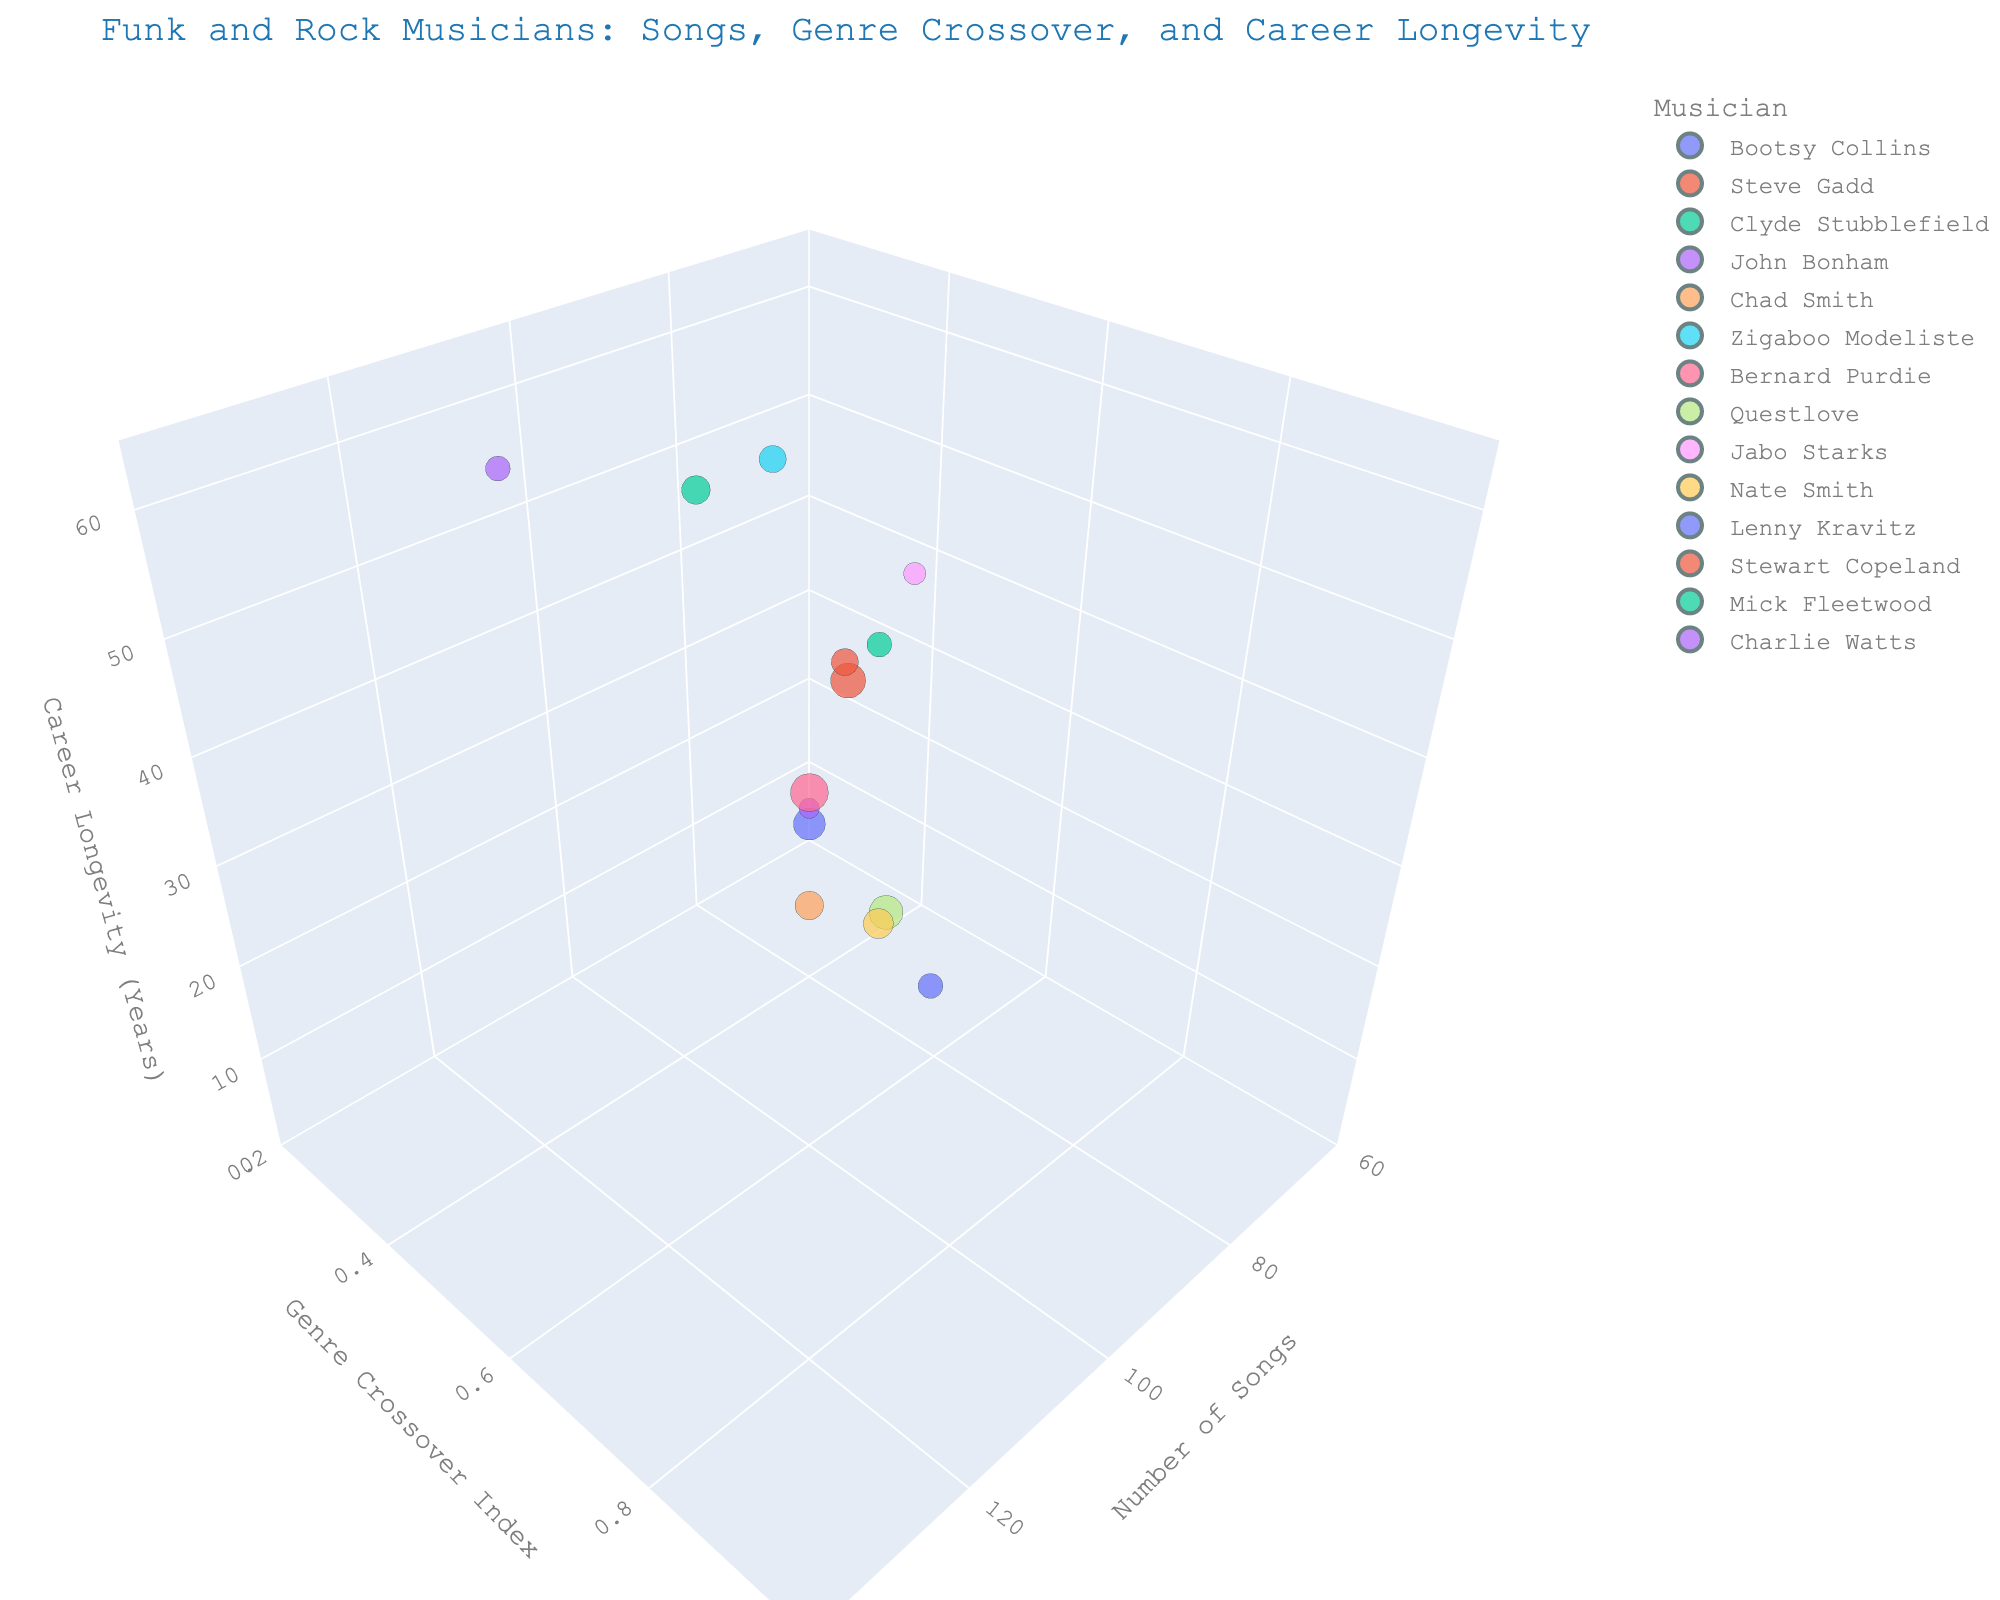what is the title of the figure? The title of the figure is usually at the top and provides an overview of the data being visualized.
Answer: Funk and Rock Musicians: Songs, Genre Crossover, and Career Longevity what are the axis labels? The x-axis, y-axis, and z-axis labels provide information about what each axis represents in the chart.
Answer: Number of Songs, Genre Crossover Index, Career Longevity (Years) which musician has the highest number of collaborations? By looking at the size of the bubbles, you can determine which is the largest, indicating the highest number of collaborations.
Answer: Bernard Purdie which musician has the highest genre crossover index? By examining the y-axis (Genre Crossover Index) and identifying the highest point, you can determine which musician has the highest genre crossover index.
Answer: Bernard Purdie how many musicians have a career longevity of at least 50 years? Examine the z-axis (Career Longevity) and count the number of bubbles with a value of 50 or higher.
Answer: 4 which musician with career longevity over 50 years has the least number of songs? Filter the bubbles by those with career longevity over 50 years (z-axis) and then compare their x-axis (Number of Songs) values to find the minimum.
Answer: Charlie Watts what's the difference in number of songs between the musician with the most songs and the one with the fewest songs? Identify the bubbles with the maximum and minimum x-axis (Number of Songs) values, then subtract the minimum value from the maximum value.
Answer: 60 what is the average genre crossover index for musicians with over 100 songs? Identify musicians with x-axis values over 100, sum their y-axis (Genre Crossover Index) values, and divide by the number of these musicians.
Answer: 0.75 which musician has the most balanced career in terms of number of songs, genre crossover, and career longevity? Look for a bubble that is relatively centered with moderate values on x, y, and z-axes, and not too small or large.
Answer: Chad Smith which musician has the highest number of songs but relatively low genre crossover? Identify the bubble with the highest x-axis (Number of Songs) value, then observe whether its y-axis (Genre Crossover Index) is low.
Answer: Bernard Purdie 